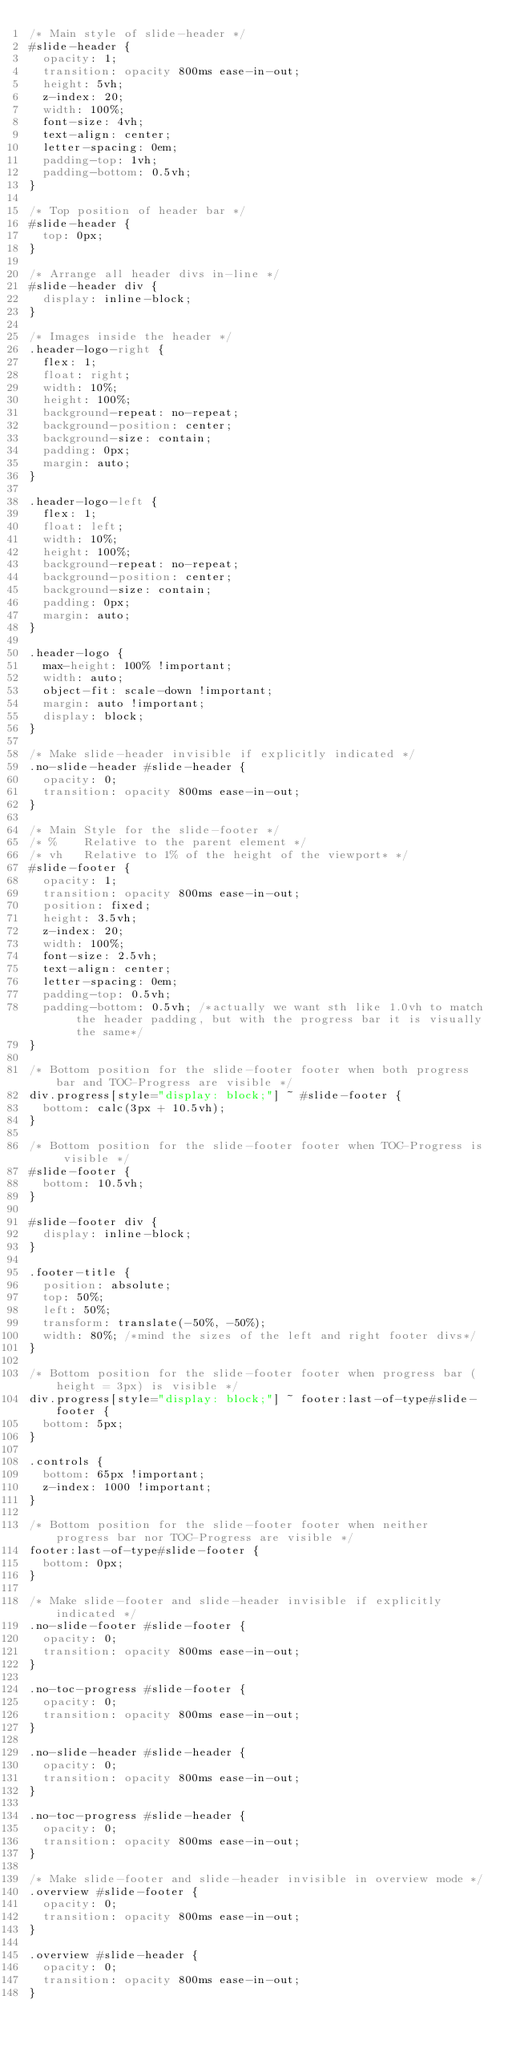<code> <loc_0><loc_0><loc_500><loc_500><_CSS_>/* Main style of slide-header */
#slide-header {
  opacity: 1;
  transition: opacity 800ms ease-in-out;
  height: 5vh;
  z-index: 20;
  width: 100%;
  font-size: 4vh;
  text-align: center;
  letter-spacing: 0em;
  padding-top: 1vh;
  padding-bottom: 0.5vh;
}

/* Top position of header bar */
#slide-header {
  top: 0px;
}

/* Arrange all header divs in-line */
#slide-header div {
  display: inline-block;
}

/* Images inside the header */
.header-logo-right {
  flex: 1;
  float: right;
  width: 10%;
  height: 100%;
  background-repeat: no-repeat;
  background-position: center;
  background-size: contain;
  padding: 0px;
  margin: auto;
}

.header-logo-left {
  flex: 1;
  float: left;
  width: 10%;
  height: 100%;
  background-repeat: no-repeat;
  background-position: center;
  background-size: contain;
  padding: 0px;
  margin: auto;
}

.header-logo {
  max-height: 100% !important;
  width: auto;
  object-fit: scale-down !important;
  margin: auto !important;
  display: block;
}

/* Make slide-header invisible if explicitly indicated */
.no-slide-header #slide-header {
  opacity: 0;
  transition: opacity 800ms ease-in-out;
}

/* Main Style for the slide-footer */
/* % 	Relative to the parent element */
/* vh 	Relative to 1% of the height of the viewport* */
#slide-footer {
  opacity: 1;
  transition: opacity 800ms ease-in-out;
  position: fixed;
  height: 3.5vh;
  z-index: 20;
  width: 100%;
  font-size: 2.5vh;
  text-align: center;
  letter-spacing: 0em;
  padding-top: 0.5vh;
  padding-bottom: 0.5vh; /*actually we want sth like 1.0vh to match the header padding, but with the progress bar it is visually the same*/
}

/* Bottom position for the slide-footer footer when both progress bar and TOC-Progress are visible */
div.progress[style="display: block;"] ~ #slide-footer {
  bottom: calc(3px + 10.5vh);
}

/* Bottom position for the slide-footer footer when TOC-Progress is visible */
#slide-footer {
  bottom: 10.5vh;
}

#slide-footer div {
  display: inline-block;
}

.footer-title {
  position: absolute;
  top: 50%;
  left: 50%;
  transform: translate(-50%, -50%);
  width: 80%; /*mind the sizes of the left and right footer divs*/
}

/* Bottom position for the slide-footer footer when progress bar (height = 3px) is visible */
div.progress[style="display: block;"] ~ footer:last-of-type#slide-footer {
  bottom: 5px;
}

.controls {
  bottom: 65px !important;
  z-index: 1000 !important;
}

/* Bottom position for the slide-footer footer when neither progress bar nor TOC-Progress are visible */
footer:last-of-type#slide-footer {
  bottom: 0px;
}

/* Make slide-footer and slide-header invisible if explicitly indicated */
.no-slide-footer #slide-footer {
  opacity: 0;
  transition: opacity 800ms ease-in-out;
}

.no-toc-progress #slide-footer {
  opacity: 0;
  transition: opacity 800ms ease-in-out;
}

.no-slide-header #slide-header {
  opacity: 0;
  transition: opacity 800ms ease-in-out;
}

.no-toc-progress #slide-header {
  opacity: 0;
  transition: opacity 800ms ease-in-out;
}

/* Make slide-footer and slide-header invisible in overview mode */
.overview #slide-footer {
  opacity: 0;
  transition: opacity 800ms ease-in-out;
}

.overview #slide-header {
  opacity: 0;
  transition: opacity 800ms ease-in-out;
}
</code> 